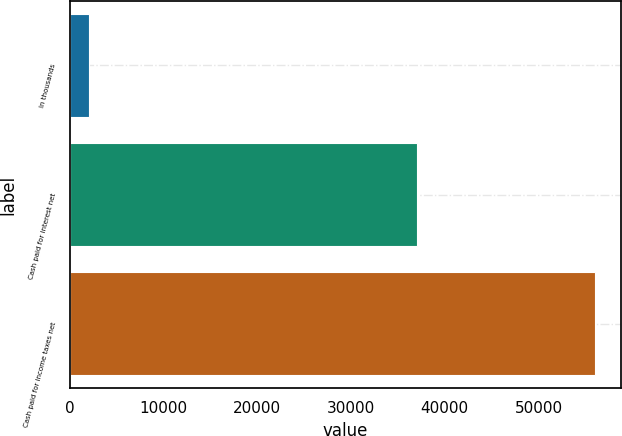Convert chart to OTSL. <chart><loc_0><loc_0><loc_500><loc_500><bar_chart><fcel>In thousands<fcel>Cash paid for interest net<fcel>Cash paid for income taxes net<nl><fcel>2010<fcel>37083<fcel>55991<nl></chart> 